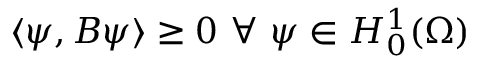<formula> <loc_0><loc_0><loc_500><loc_500>\langle \psi , B \psi \rangle \geq 0 \ \forall \ \psi \in H _ { 0 } ^ { 1 } ( \Omega )</formula> 